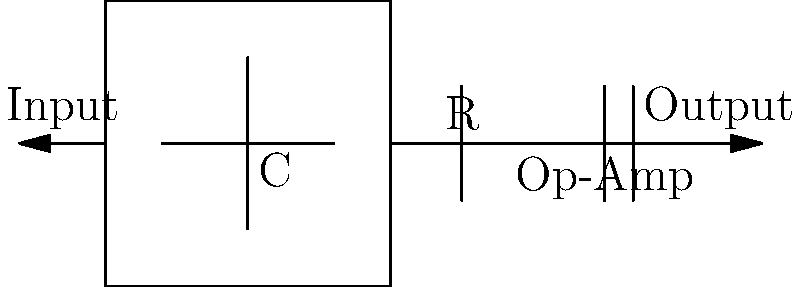In the schematic representation of a basic heart rate monitor circuit shown above, what is the primary purpose of the capacitor (C) and resistor (R) combination? To understand the purpose of the capacitor (C) and resistor (R) combination in this basic heart rate monitor circuit, let's break it down step-by-step:

1. Input signal: The heart rate monitor receives an input signal from sensors placed on the skin. This signal is typically weak and contains noise.

2. Capacitor (C) function: 
   - Acts as a high-pass filter
   - Blocks DC components and very low-frequency noise
   - Allows the AC component of the heart rate signal to pass through

3. Resistor (R) function:
   - Forms a voltage divider with the capacitor
   - Helps set the cut-off frequency of the high-pass filter
   - Provides a path for the input bias current of the op-amp

4. RC combination:
   - Together, C and R form a high-pass filter
   - The cut-off frequency is given by the formula $f_c = \frac{1}{2\pi RC}$
   - This filter attenuates low-frequency noise and baseline drift

5. Op-Amp stage:
   - Amplifies the filtered signal
   - Provides a clean, amplified output of the heart rate signal

In summary, the primary purpose of the capacitor (C) and resistor (R) combination is to form a high-pass filter. This filter removes unwanted low-frequency components and DC offset from the input signal, allowing only the relevant heart rate signal to pass through for amplification by the op-amp.
Answer: High-pass filter 